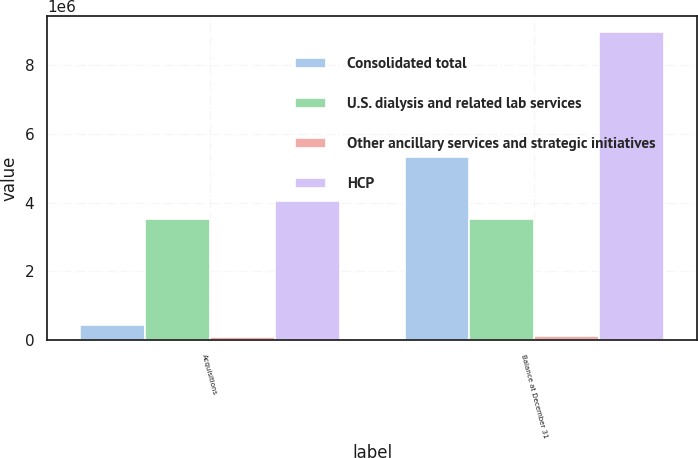Convert chart. <chart><loc_0><loc_0><loc_500><loc_500><stacked_bar_chart><ecel><fcel>Acquisitions<fcel>Balance at December 31<nl><fcel>Consolidated total<fcel>443997<fcel>5.30915e+06<nl><fcel>U.S. dialysis and related lab services<fcel>3.51879e+06<fcel>3.51879e+06<nl><fcel>Other ancillary services and strategic initiatives<fcel>88611<fcel>137027<nl><fcel>HCP<fcel>4.0514e+06<fcel>8.96497e+06<nl></chart> 